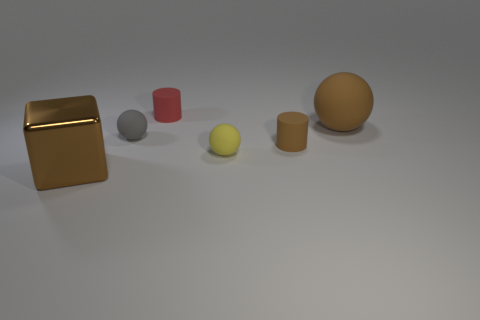There is a brown object that is behind the large metallic cube and in front of the brown ball; how big is it?
Your response must be concise. Small. Are there more brown rubber cylinders that are in front of the small yellow matte ball than large cyan matte spheres?
Provide a short and direct response. No. How many balls are either gray things or tiny blue metallic objects?
Your response must be concise. 1. The object that is behind the gray object and on the right side of the yellow ball has what shape?
Give a very brief answer. Sphere. Are there the same number of tiny matte things that are left of the tiny gray matte thing and cylinders that are in front of the red cylinder?
Offer a very short reply. No. What number of things are either big brown rubber balls or small cylinders?
Offer a terse response. 3. There is a cube that is the same size as the brown sphere; what color is it?
Give a very brief answer. Brown. How many objects are matte things behind the brown rubber ball or small rubber objects that are in front of the small gray matte thing?
Your response must be concise. 3. Is the number of big things that are on the right side of the big shiny block the same as the number of green cubes?
Give a very brief answer. No. Is the size of the brown object to the left of the red rubber cylinder the same as the ball that is on the right side of the small yellow rubber sphere?
Offer a very short reply. Yes. 